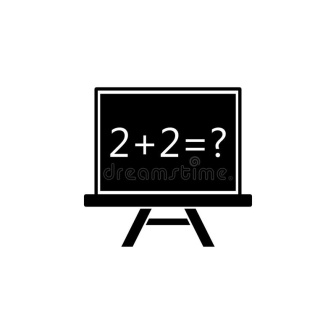Can you elaborate on the elements of the picture provided? The image depicts a simple yet intriguing scene with a central chalkboard standing upright on a pair of legs, starkly contrasting the white background. Inscribed on the chalkboard in bold handwriting is the arithmetic equation '2 + 2 = ?', a fundamental yet engaging prompt that invites viewers to solve it. The question mark encourages interaction, making the viewer an active participant in this mathematical exercise. There is a sense of symmetry and balance in the image, with the chalkboard firmly positioned between its two supporting legs, creating a unified entity that stands out against the pristine backdrop. The entire image conveys a sense of readiness and anticipation, as if waiting for the observer to respond to the timeless query. 